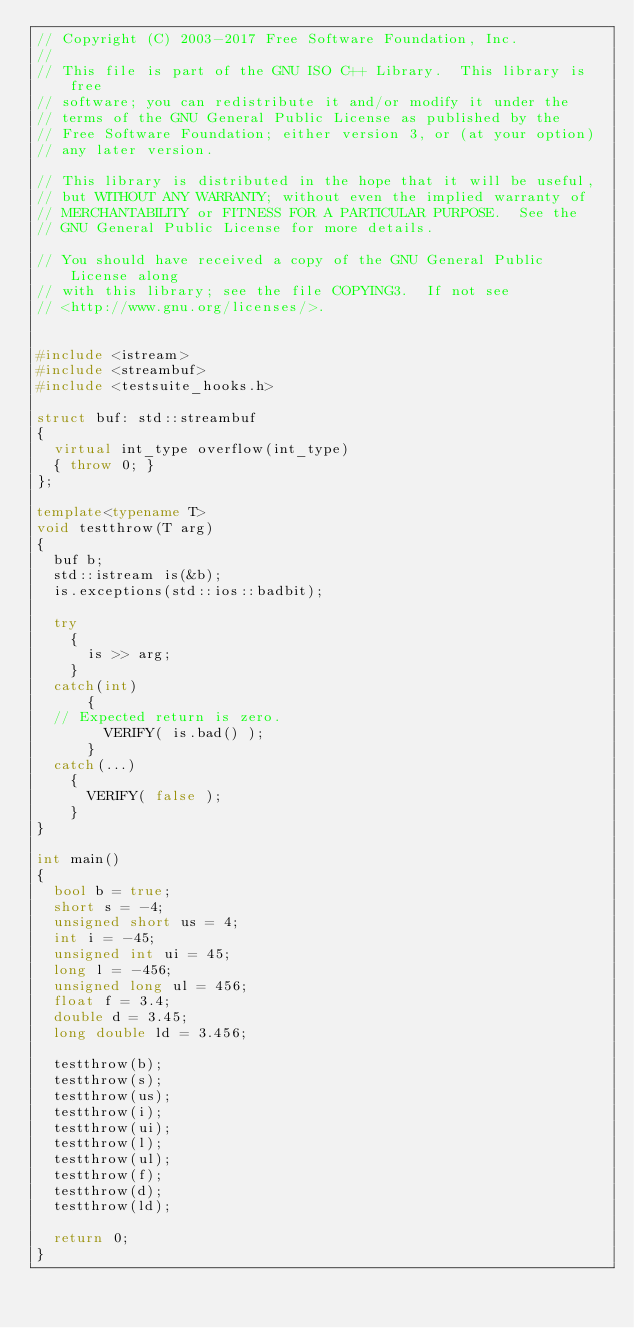Convert code to text. <code><loc_0><loc_0><loc_500><loc_500><_C++_>// Copyright (C) 2003-2017 Free Software Foundation, Inc.
//
// This file is part of the GNU ISO C++ Library.  This library is free
// software; you can redistribute it and/or modify it under the
// terms of the GNU General Public License as published by the
// Free Software Foundation; either version 3, or (at your option)
// any later version.

// This library is distributed in the hope that it will be useful,
// but WITHOUT ANY WARRANTY; without even the implied warranty of
// MERCHANTABILITY or FITNESS FOR A PARTICULAR PURPOSE.  See the
// GNU General Public License for more details.

// You should have received a copy of the GNU General Public License along
// with this library; see the file COPYING3.  If not see
// <http://www.gnu.org/licenses/>.


#include <istream>
#include <streambuf>
#include <testsuite_hooks.h>

struct buf: std::streambuf
{
  virtual int_type overflow(int_type) 
  { throw 0; }
};

template<typename T>
void testthrow(T arg)
{
  buf b;
  std::istream is(&b);
  is.exceptions(std::ios::badbit);

  try 
    {
      is >> arg;
    }
  catch(int) 
      {
	// Expected return is zero.
        VERIFY( is.bad() );
      }
  catch(...) 
    {
      VERIFY( false );
    }    
}

int main()
{
  bool b = true;
  short s = -4; 
  unsigned short us = 4;
  int i = -45; 
  unsigned int ui = 45;
  long l = -456;
  unsigned long ul = 456;
  float f = 3.4;
  double d = 3.45;
  long double ld = 3.456;

  testthrow(b);
  testthrow(s);
  testthrow(us);
  testthrow(i);
  testthrow(ui);
  testthrow(l);
  testthrow(ul);
  testthrow(f);
  testthrow(d);
  testthrow(ld);

  return 0;
}
</code> 